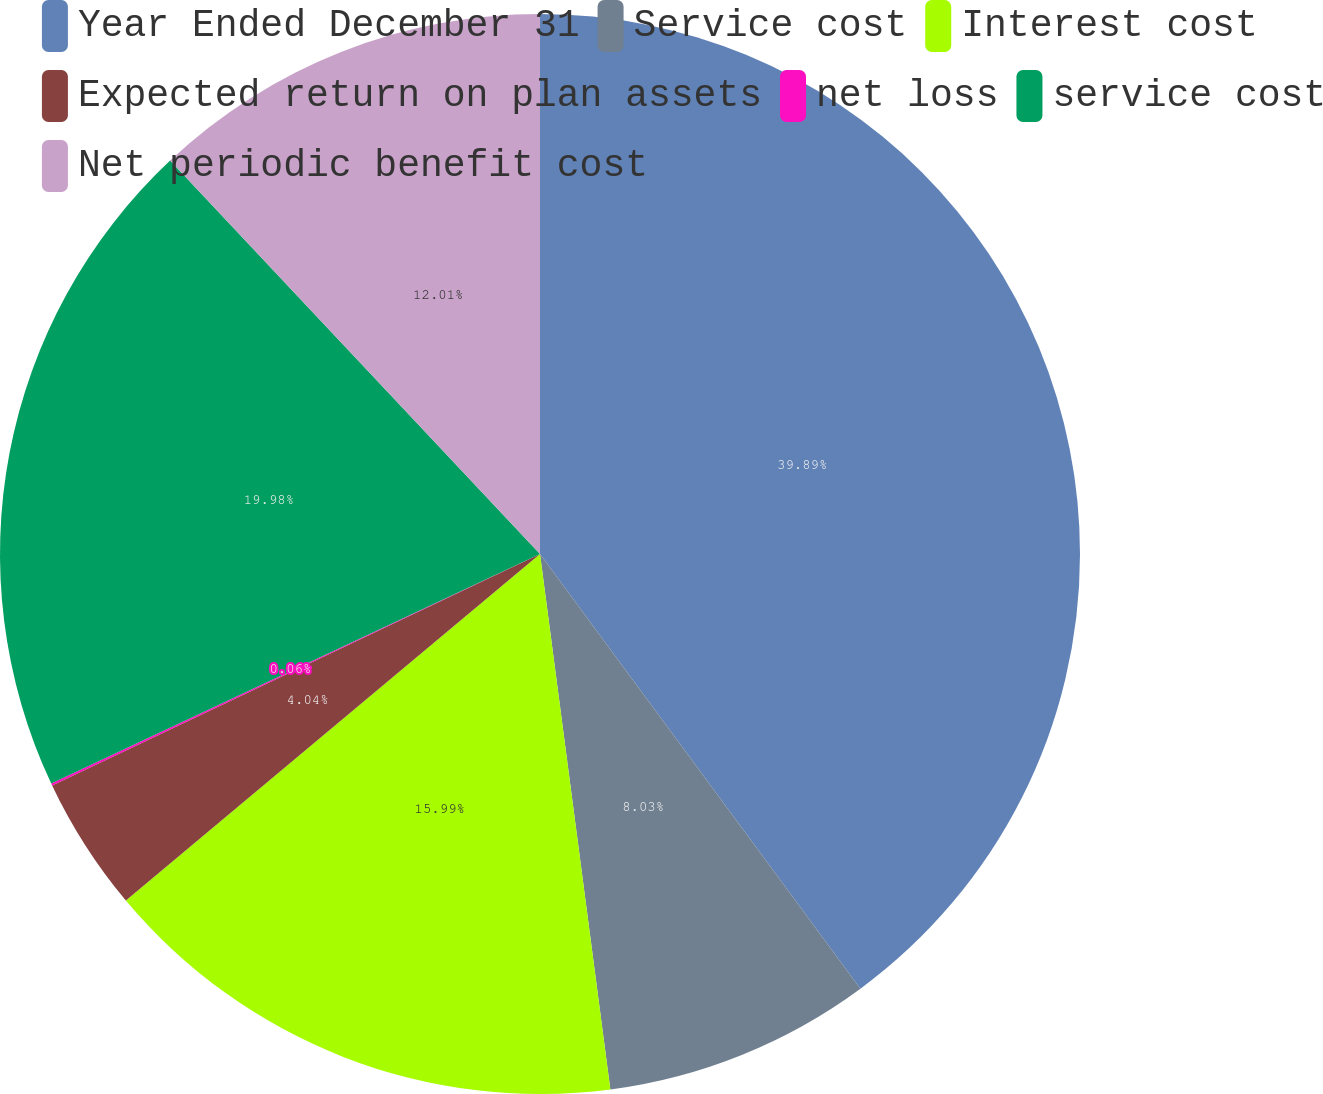Convert chart to OTSL. <chart><loc_0><loc_0><loc_500><loc_500><pie_chart><fcel>Year Ended December 31<fcel>Service cost<fcel>Interest cost<fcel>Expected return on plan assets<fcel>net loss<fcel>service cost<fcel>Net periodic benefit cost<nl><fcel>39.89%<fcel>8.03%<fcel>15.99%<fcel>4.04%<fcel>0.06%<fcel>19.98%<fcel>12.01%<nl></chart> 